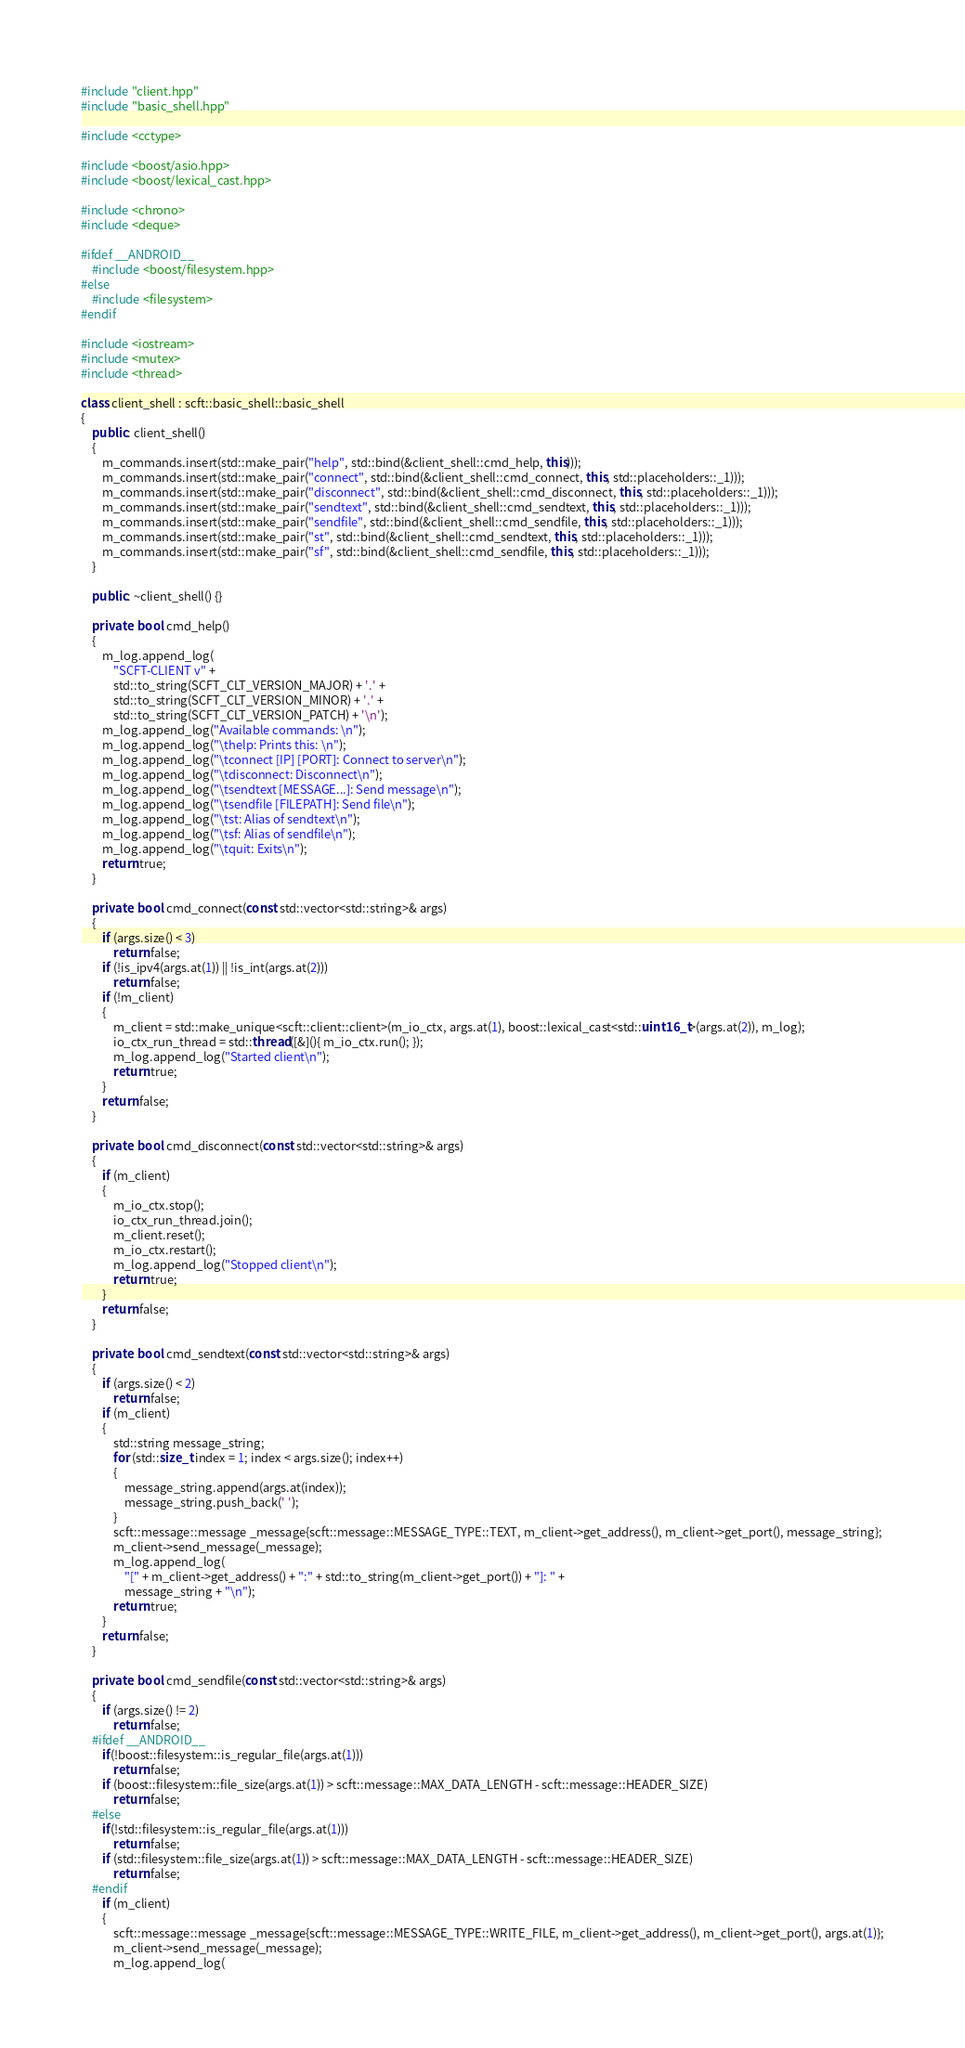Convert code to text. <code><loc_0><loc_0><loc_500><loc_500><_C++_>#include "client.hpp"
#include "basic_shell.hpp"

#include <cctype>

#include <boost/asio.hpp>
#include <boost/lexical_cast.hpp>

#include <chrono>
#include <deque>

#ifdef __ANDROID__
    #include <boost/filesystem.hpp>
#else
    #include <filesystem>
#endif

#include <iostream>
#include <mutex>
#include <thread>

class client_shell : scft::basic_shell::basic_shell
{
    public: client_shell()
    {
        m_commands.insert(std::make_pair("help", std::bind(&client_shell::cmd_help, this)));
        m_commands.insert(std::make_pair("connect", std::bind(&client_shell::cmd_connect, this, std::placeholders::_1)));
        m_commands.insert(std::make_pair("disconnect", std::bind(&client_shell::cmd_disconnect, this, std::placeholders::_1)));
        m_commands.insert(std::make_pair("sendtext", std::bind(&client_shell::cmd_sendtext, this, std::placeholders::_1)));
        m_commands.insert(std::make_pair("sendfile", std::bind(&client_shell::cmd_sendfile, this, std::placeholders::_1)));
        m_commands.insert(std::make_pair("st", std::bind(&client_shell::cmd_sendtext, this, std::placeholders::_1)));
        m_commands.insert(std::make_pair("sf", std::bind(&client_shell::cmd_sendfile, this, std::placeholders::_1)));
    }

    public: ~client_shell() {}

    private: bool cmd_help()
    {
        m_log.append_log(
            "SCFT-CLIENT v" +
            std::to_string(SCFT_CLT_VERSION_MAJOR) + '.' +
            std::to_string(SCFT_CLT_VERSION_MINOR) + '.' +
            std::to_string(SCFT_CLT_VERSION_PATCH) + '\n');
        m_log.append_log("Available commands: \n");
        m_log.append_log("\thelp: Prints this: \n");
        m_log.append_log("\tconnect [IP] [PORT]: Connect to server\n");
        m_log.append_log("\tdisconnect: Disconnect\n");
        m_log.append_log("\tsendtext [MESSAGE...]: Send message\n");
        m_log.append_log("\tsendfile [FILEPATH]: Send file\n");
        m_log.append_log("\tst: Alias of sendtext\n");
        m_log.append_log("\tsf: Alias of sendfile\n");
        m_log.append_log("\tquit: Exits\n");
        return true;
    }

    private: bool cmd_connect(const std::vector<std::string>& args)
    {
        if (args.size() < 3)
            return false;
        if (!is_ipv4(args.at(1)) || !is_int(args.at(2)))
            return false;
        if (!m_client)
        {
            m_client = std::make_unique<scft::client::client>(m_io_ctx, args.at(1), boost::lexical_cast<std::uint16_t>(args.at(2)), m_log);
            io_ctx_run_thread = std::thread([&](){ m_io_ctx.run(); });
            m_log.append_log("Started client\n");
            return true;
        }
        return false;
    }

    private: bool cmd_disconnect(const std::vector<std::string>& args)
    {
        if (m_client)
        {
            m_io_ctx.stop();
            io_ctx_run_thread.join();
            m_client.reset();
            m_io_ctx.restart();
            m_log.append_log("Stopped client\n");
            return true;
        }
        return false;
    }

    private: bool cmd_sendtext(const std::vector<std::string>& args)
    {
        if (args.size() < 2)
            return false;
        if (m_client)
        {
            std::string message_string;
            for (std::size_t index = 1; index < args.size(); index++)
            {
                message_string.append(args.at(index));
                message_string.push_back(' ');
            }
            scft::message::message _message{scft::message::MESSAGE_TYPE::TEXT, m_client->get_address(), m_client->get_port(), message_string};
            m_client->send_message(_message);
            m_log.append_log(
                "[" + m_client->get_address() + ":" + std::to_string(m_client->get_port()) + "]: " +
                message_string + "\n");
            return true;
        }
        return false;
    }

    private: bool cmd_sendfile(const std::vector<std::string>& args)
    {
        if (args.size() != 2)
            return false;
    #ifdef __ANDROID__
        if(!boost::filesystem::is_regular_file(args.at(1)))
            return false;
        if (boost::filesystem::file_size(args.at(1)) > scft::message::MAX_DATA_LENGTH - scft::message::HEADER_SIZE)
            return false;
    #else
        if(!std::filesystem::is_regular_file(args.at(1)))
            return false;
        if (std::filesystem::file_size(args.at(1)) > scft::message::MAX_DATA_LENGTH - scft::message::HEADER_SIZE)
            return false;
    #endif
        if (m_client)
        {
            scft::message::message _message{scft::message::MESSAGE_TYPE::WRITE_FILE, m_client->get_address(), m_client->get_port(), args.at(1)};
            m_client->send_message(_message);
            m_log.append_log(</code> 